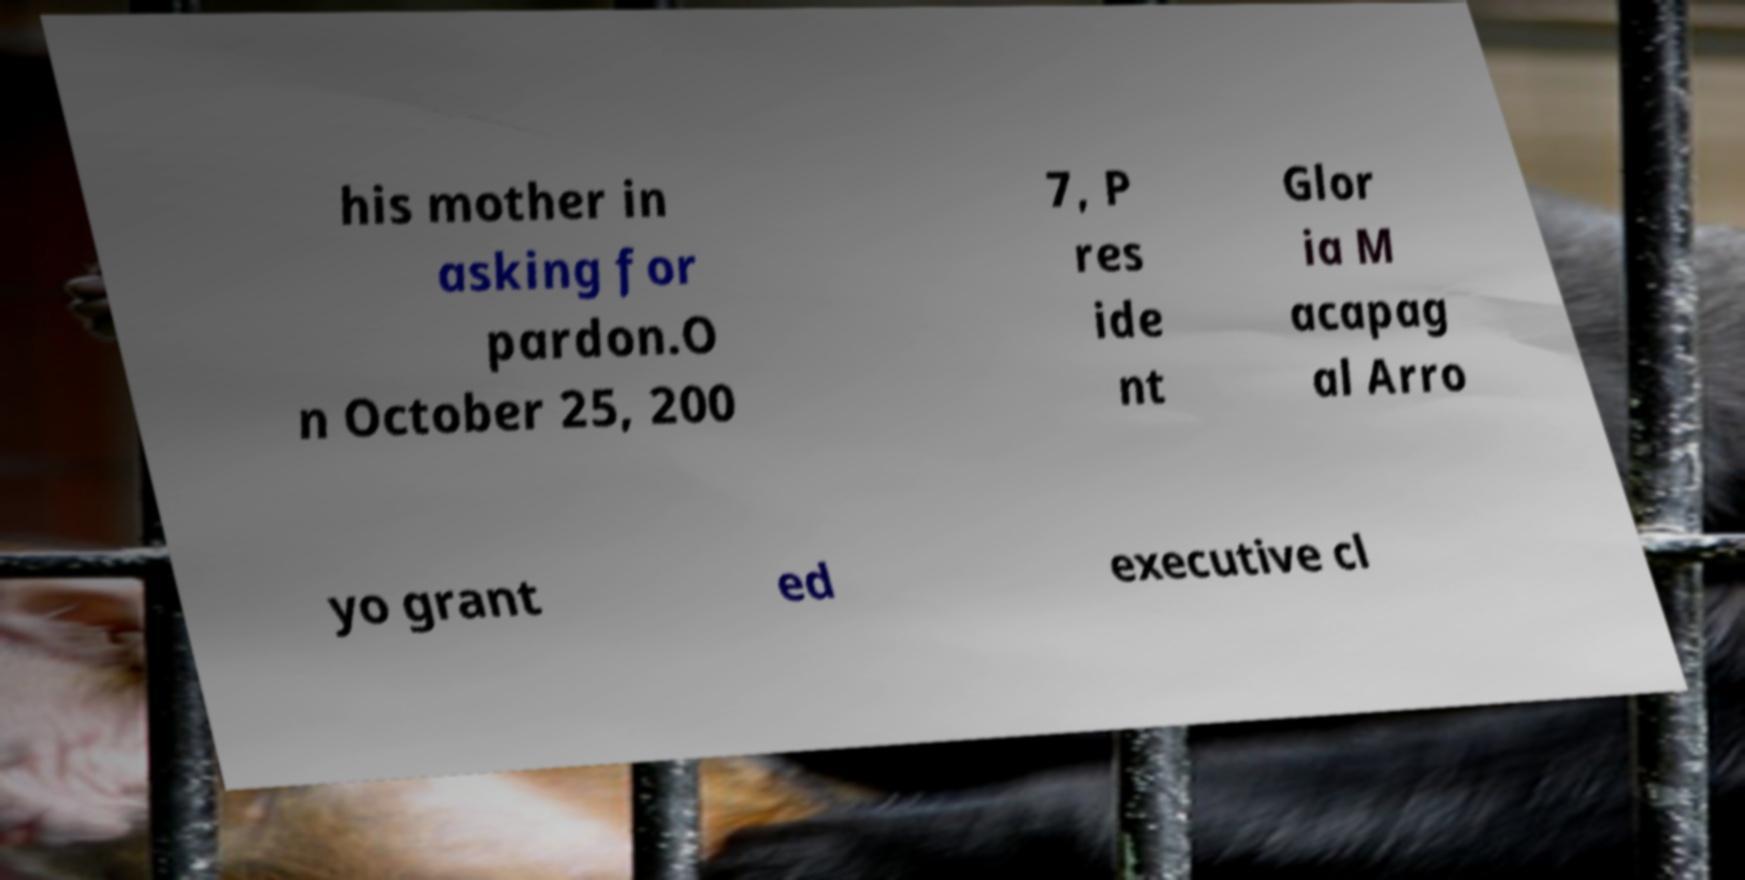Can you read and provide the text displayed in the image?This photo seems to have some interesting text. Can you extract and type it out for me? his mother in asking for pardon.O n October 25, 200 7, P res ide nt Glor ia M acapag al Arro yo grant ed executive cl 